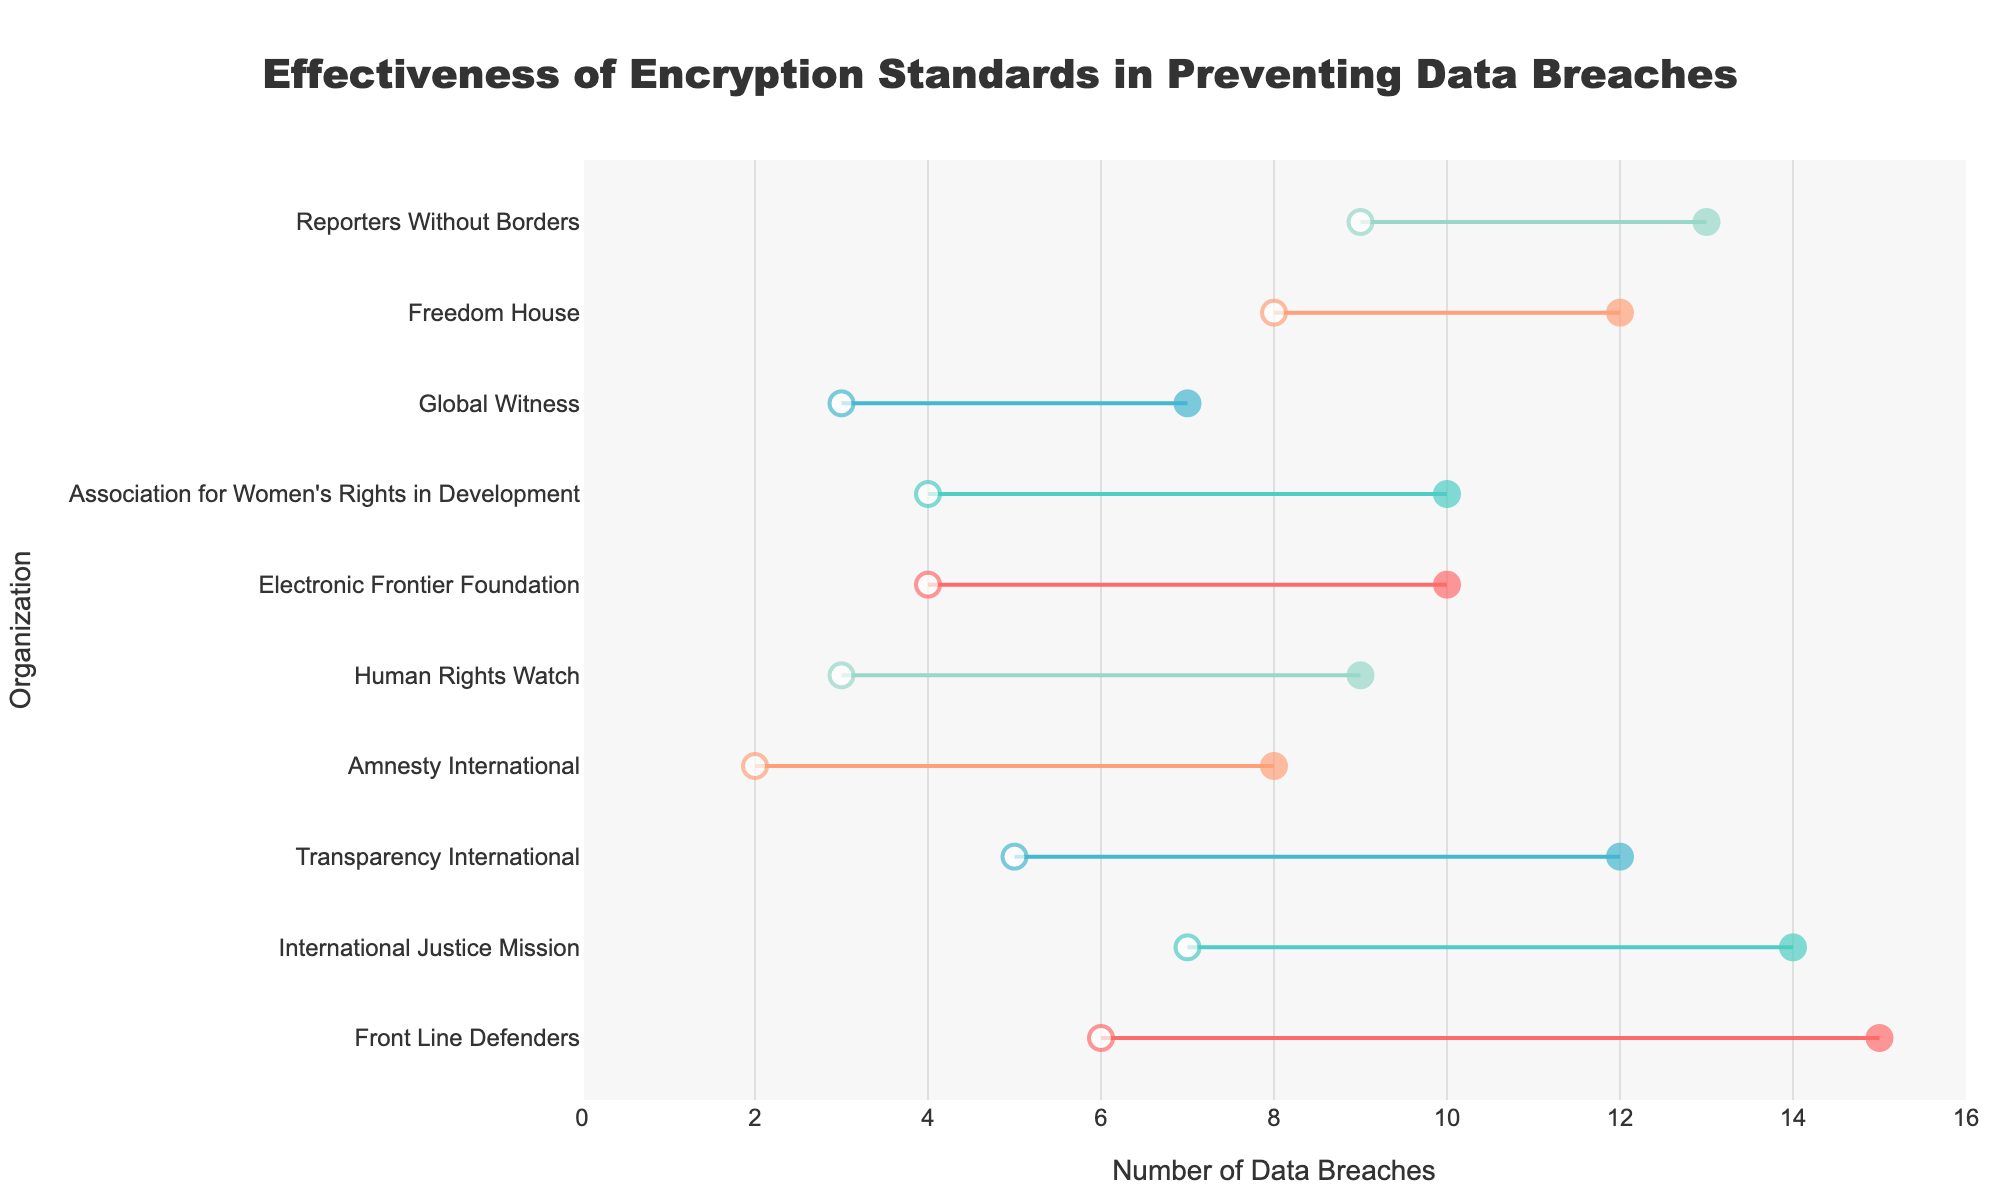What is the title of the figure? The title of the figure is usually displayed prominently at the top. In this case, it specifies that the figure is about the effectiveness of encryption standards in preventing data breaches.
Answer: Effectiveness of Encryption Standards in Preventing Data Breaches How many organizations experienced a reduction in data breaches after implementing encryption? Each line in the dumbbell plot represents an organization. By counting the number of lines that show a decrease from the left marker (before) to the right marker (after), we can determine this number. All organizations listed show a reduction.
Answer: 10 Which encryption standard showed the greatest reduction in data breaches? To determine the greatest reduction, calculate the difference between 'Before Implementation' and 'After Implementation' for each encryption standard used by organizations and identify the largest difference.
Answer: Blowfish How many data breaches were prevented at Amnesty International after implementing AES-256? The difference between the 'Before Implementation' and 'After Implementation' values for Amnesty International using AES-256 will provide the number of data breaches prevented.
Answer: 6 Which organization had the highest number of data breaches before implementation of encryption standards? Identify the 'Before Implementation' values and find the maximum value among them, then check which organization corresponds to that value.
Answer: Front Line Defenders How does the number of data breaches before implementation compare between Transparency International and Association for Women's Rights in Development when using Twofish? Compare the 'Before Implementation' values for both organizations using Twofish to see which has a higher initial number of data breaches.
Answer: Transparency International had more breaches before implementation (12 vs. 10) What is the average number of data breaches prevented across all organizations after implementation? To find the average reduction, subtract the 'After Implementation' from the 'Before Implementation' for each organization, then sum these differences and divide by the number of organizations.
Answer: 5.1 Which encryption standard is used by the organization that had the least reduction in data breaches? Calculate the difference between 'Before Implementation' and 'After Implementation' for each organization and find the organization with the smallest reduction, then check its encryption standard.
Answer: 3DES How many different encryption standards are represented in the figure? Count the distinct encryption standard values listed in the data.
Answer: 5 What is the total number of data breaches prevented after implementing the Blowfish encryption standard? Identify the organizations using Blowfish, calculate the reduction in data breaches for each, and sum these reductions together.
Answer: 16 